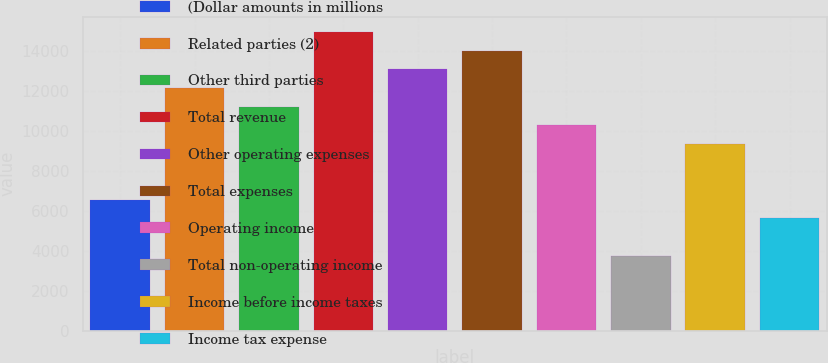Convert chart. <chart><loc_0><loc_0><loc_500><loc_500><bar_chart><fcel>(Dollar amounts in millions<fcel>Related parties (2)<fcel>Other third parties<fcel>Total revenue<fcel>Other operating expenses<fcel>Total expenses<fcel>Operating income<fcel>Total non-operating income<fcel>Income before income taxes<fcel>Income tax expense<nl><fcel>6537.7<fcel>12136.3<fcel>11203.2<fcel>14935.6<fcel>13069.4<fcel>14002.5<fcel>10270.1<fcel>3738.4<fcel>9337<fcel>5604.6<nl></chart> 